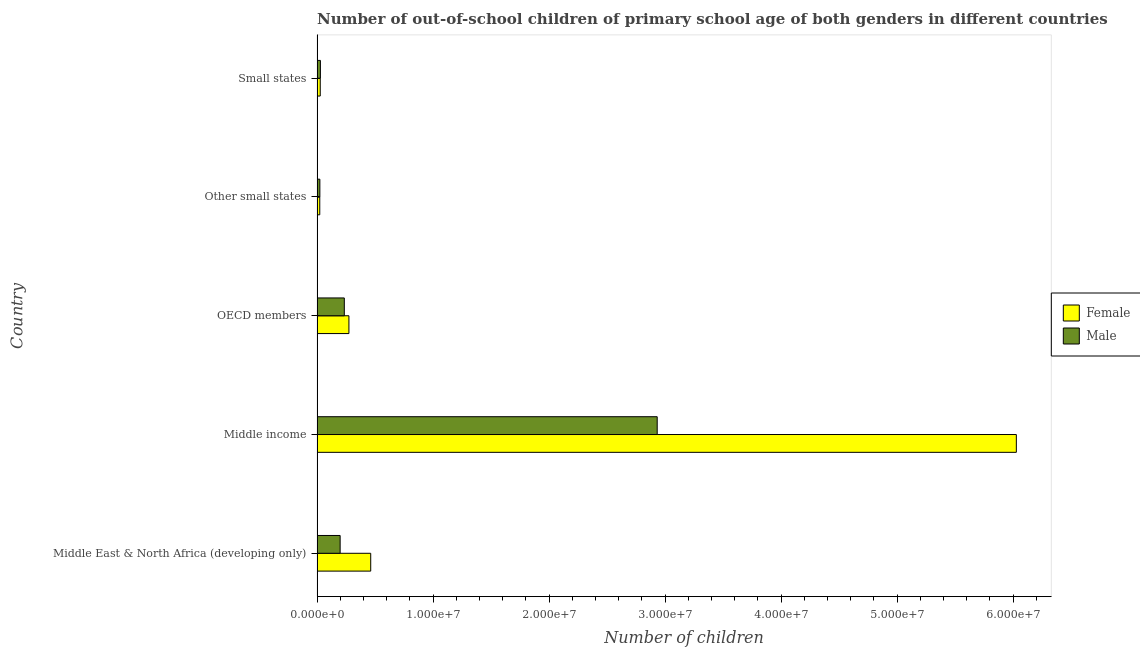How many different coloured bars are there?
Your answer should be compact. 2. Are the number of bars on each tick of the Y-axis equal?
Offer a terse response. Yes. How many bars are there on the 1st tick from the top?
Your answer should be compact. 2. What is the label of the 1st group of bars from the top?
Your response must be concise. Small states. In how many cases, is the number of bars for a given country not equal to the number of legend labels?
Your response must be concise. 0. What is the number of male out-of-school students in Middle East & North Africa (developing only)?
Provide a short and direct response. 1.99e+06. Across all countries, what is the maximum number of male out-of-school students?
Your answer should be very brief. 2.93e+07. Across all countries, what is the minimum number of female out-of-school students?
Ensure brevity in your answer.  2.34e+05. In which country was the number of male out-of-school students minimum?
Ensure brevity in your answer.  Other small states. What is the total number of male out-of-school students in the graph?
Give a very brief answer. 3.42e+07. What is the difference between the number of male out-of-school students in OECD members and that in Other small states?
Offer a very short reply. 2.11e+06. What is the difference between the number of female out-of-school students in Small states and the number of male out-of-school students in Middle East & North Africa (developing only)?
Your answer should be very brief. -1.71e+06. What is the average number of female out-of-school students per country?
Your answer should be very brief. 1.36e+07. What is the difference between the number of female out-of-school students and number of male out-of-school students in OECD members?
Offer a very short reply. 3.97e+05. In how many countries, is the number of male out-of-school students greater than 2000000 ?
Your answer should be very brief. 2. What is the ratio of the number of male out-of-school students in Middle East & North Africa (developing only) to that in Middle income?
Give a very brief answer. 0.07. Is the number of male out-of-school students in Middle East & North Africa (developing only) less than that in Other small states?
Your answer should be very brief. No. What is the difference between the highest and the second highest number of female out-of-school students?
Keep it short and to the point. 5.56e+07. What is the difference between the highest and the lowest number of female out-of-school students?
Give a very brief answer. 6.00e+07. In how many countries, is the number of male out-of-school students greater than the average number of male out-of-school students taken over all countries?
Your answer should be very brief. 1. What does the 2nd bar from the bottom in Small states represents?
Offer a terse response. Male. Are the values on the major ticks of X-axis written in scientific E-notation?
Provide a short and direct response. Yes. Does the graph contain grids?
Your answer should be compact. No. Where does the legend appear in the graph?
Keep it short and to the point. Center right. How are the legend labels stacked?
Provide a short and direct response. Vertical. What is the title of the graph?
Provide a succinct answer. Number of out-of-school children of primary school age of both genders in different countries. Does "IMF nonconcessional" appear as one of the legend labels in the graph?
Offer a terse response. No. What is the label or title of the X-axis?
Your response must be concise. Number of children. What is the label or title of the Y-axis?
Keep it short and to the point. Country. What is the Number of children of Female in Middle East & North Africa (developing only)?
Your answer should be compact. 4.63e+06. What is the Number of children in Male in Middle East & North Africa (developing only)?
Offer a terse response. 1.99e+06. What is the Number of children of Female in Middle income?
Your answer should be compact. 6.03e+07. What is the Number of children of Male in Middle income?
Provide a short and direct response. 2.93e+07. What is the Number of children of Female in OECD members?
Ensure brevity in your answer.  2.75e+06. What is the Number of children in Male in OECD members?
Offer a very short reply. 2.35e+06. What is the Number of children in Female in Other small states?
Your answer should be very brief. 2.34e+05. What is the Number of children in Male in Other small states?
Provide a short and direct response. 2.42e+05. What is the Number of children of Female in Small states?
Provide a succinct answer. 2.76e+05. What is the Number of children of Male in Small states?
Your answer should be very brief. 2.89e+05. Across all countries, what is the maximum Number of children in Female?
Give a very brief answer. 6.03e+07. Across all countries, what is the maximum Number of children in Male?
Offer a very short reply. 2.93e+07. Across all countries, what is the minimum Number of children in Female?
Provide a short and direct response. 2.34e+05. Across all countries, what is the minimum Number of children of Male?
Your answer should be compact. 2.42e+05. What is the total Number of children in Female in the graph?
Keep it short and to the point. 6.82e+07. What is the total Number of children of Male in the graph?
Give a very brief answer. 3.42e+07. What is the difference between the Number of children in Female in Middle East & North Africa (developing only) and that in Middle income?
Offer a very short reply. -5.56e+07. What is the difference between the Number of children in Male in Middle East & North Africa (developing only) and that in Middle income?
Provide a short and direct response. -2.73e+07. What is the difference between the Number of children in Female in Middle East & North Africa (developing only) and that in OECD members?
Your response must be concise. 1.88e+06. What is the difference between the Number of children in Male in Middle East & North Africa (developing only) and that in OECD members?
Offer a terse response. -3.60e+05. What is the difference between the Number of children of Female in Middle East & North Africa (developing only) and that in Other small states?
Provide a succinct answer. 4.39e+06. What is the difference between the Number of children of Male in Middle East & North Africa (developing only) and that in Other small states?
Your answer should be compact. 1.75e+06. What is the difference between the Number of children in Female in Middle East & North Africa (developing only) and that in Small states?
Give a very brief answer. 4.35e+06. What is the difference between the Number of children of Male in Middle East & North Africa (developing only) and that in Small states?
Give a very brief answer. 1.70e+06. What is the difference between the Number of children in Female in Middle income and that in OECD members?
Offer a terse response. 5.75e+07. What is the difference between the Number of children in Male in Middle income and that in OECD members?
Your answer should be compact. 2.70e+07. What is the difference between the Number of children of Female in Middle income and that in Other small states?
Offer a terse response. 6.00e+07. What is the difference between the Number of children in Male in Middle income and that in Other small states?
Your answer should be very brief. 2.91e+07. What is the difference between the Number of children in Female in Middle income and that in Small states?
Keep it short and to the point. 6.00e+07. What is the difference between the Number of children of Male in Middle income and that in Small states?
Offer a very short reply. 2.90e+07. What is the difference between the Number of children in Female in OECD members and that in Other small states?
Give a very brief answer. 2.51e+06. What is the difference between the Number of children in Male in OECD members and that in Other small states?
Keep it short and to the point. 2.11e+06. What is the difference between the Number of children in Female in OECD members and that in Small states?
Your answer should be compact. 2.47e+06. What is the difference between the Number of children of Male in OECD members and that in Small states?
Your response must be concise. 2.06e+06. What is the difference between the Number of children of Female in Other small states and that in Small states?
Keep it short and to the point. -4.15e+04. What is the difference between the Number of children of Male in Other small states and that in Small states?
Your answer should be compact. -4.67e+04. What is the difference between the Number of children in Female in Middle East & North Africa (developing only) and the Number of children in Male in Middle income?
Make the answer very short. -2.47e+07. What is the difference between the Number of children in Female in Middle East & North Africa (developing only) and the Number of children in Male in OECD members?
Your response must be concise. 2.28e+06. What is the difference between the Number of children in Female in Middle East & North Africa (developing only) and the Number of children in Male in Other small states?
Offer a terse response. 4.38e+06. What is the difference between the Number of children in Female in Middle East & North Africa (developing only) and the Number of children in Male in Small states?
Your answer should be compact. 4.34e+06. What is the difference between the Number of children in Female in Middle income and the Number of children in Male in OECD members?
Offer a terse response. 5.79e+07. What is the difference between the Number of children of Female in Middle income and the Number of children of Male in Other small states?
Your response must be concise. 6.00e+07. What is the difference between the Number of children of Female in Middle income and the Number of children of Male in Small states?
Provide a succinct answer. 6.00e+07. What is the difference between the Number of children in Female in OECD members and the Number of children in Male in Other small states?
Provide a succinct answer. 2.51e+06. What is the difference between the Number of children of Female in OECD members and the Number of children of Male in Small states?
Offer a terse response. 2.46e+06. What is the difference between the Number of children of Female in Other small states and the Number of children of Male in Small states?
Keep it short and to the point. -5.46e+04. What is the average Number of children of Female per country?
Give a very brief answer. 1.36e+07. What is the average Number of children of Male per country?
Keep it short and to the point. 6.84e+06. What is the difference between the Number of children in Female and Number of children in Male in Middle East & North Africa (developing only)?
Your answer should be compact. 2.64e+06. What is the difference between the Number of children of Female and Number of children of Male in Middle income?
Make the answer very short. 3.10e+07. What is the difference between the Number of children of Female and Number of children of Male in OECD members?
Your response must be concise. 3.97e+05. What is the difference between the Number of children of Female and Number of children of Male in Other small states?
Make the answer very short. -7915. What is the difference between the Number of children of Female and Number of children of Male in Small states?
Provide a short and direct response. -1.31e+04. What is the ratio of the Number of children in Female in Middle East & North Africa (developing only) to that in Middle income?
Make the answer very short. 0.08. What is the ratio of the Number of children in Male in Middle East & North Africa (developing only) to that in Middle income?
Ensure brevity in your answer.  0.07. What is the ratio of the Number of children of Female in Middle East & North Africa (developing only) to that in OECD members?
Your response must be concise. 1.68. What is the ratio of the Number of children of Male in Middle East & North Africa (developing only) to that in OECD members?
Your answer should be compact. 0.85. What is the ratio of the Number of children in Female in Middle East & North Africa (developing only) to that in Other small states?
Ensure brevity in your answer.  19.74. What is the ratio of the Number of children in Male in Middle East & North Africa (developing only) to that in Other small states?
Ensure brevity in your answer.  8.22. What is the ratio of the Number of children in Female in Middle East & North Africa (developing only) to that in Small states?
Give a very brief answer. 16.77. What is the ratio of the Number of children of Male in Middle East & North Africa (developing only) to that in Small states?
Your answer should be very brief. 6.89. What is the ratio of the Number of children in Female in Middle income to that in OECD members?
Ensure brevity in your answer.  21.94. What is the ratio of the Number of children in Male in Middle income to that in OECD members?
Offer a terse response. 12.48. What is the ratio of the Number of children of Female in Middle income to that in Other small states?
Offer a terse response. 257.25. What is the ratio of the Number of children in Male in Middle income to that in Other small states?
Give a very brief answer. 121.05. What is the ratio of the Number of children in Female in Middle income to that in Small states?
Give a very brief answer. 218.55. What is the ratio of the Number of children in Male in Middle income to that in Small states?
Provide a succinct answer. 101.48. What is the ratio of the Number of children of Female in OECD members to that in Other small states?
Keep it short and to the point. 11.73. What is the ratio of the Number of children in Male in OECD members to that in Other small states?
Ensure brevity in your answer.  9.7. What is the ratio of the Number of children of Female in OECD members to that in Small states?
Your answer should be very brief. 9.96. What is the ratio of the Number of children in Male in OECD members to that in Small states?
Ensure brevity in your answer.  8.13. What is the ratio of the Number of children in Female in Other small states to that in Small states?
Ensure brevity in your answer.  0.85. What is the ratio of the Number of children in Male in Other small states to that in Small states?
Ensure brevity in your answer.  0.84. What is the difference between the highest and the second highest Number of children of Female?
Offer a very short reply. 5.56e+07. What is the difference between the highest and the second highest Number of children in Male?
Give a very brief answer. 2.70e+07. What is the difference between the highest and the lowest Number of children in Female?
Keep it short and to the point. 6.00e+07. What is the difference between the highest and the lowest Number of children in Male?
Offer a terse response. 2.91e+07. 